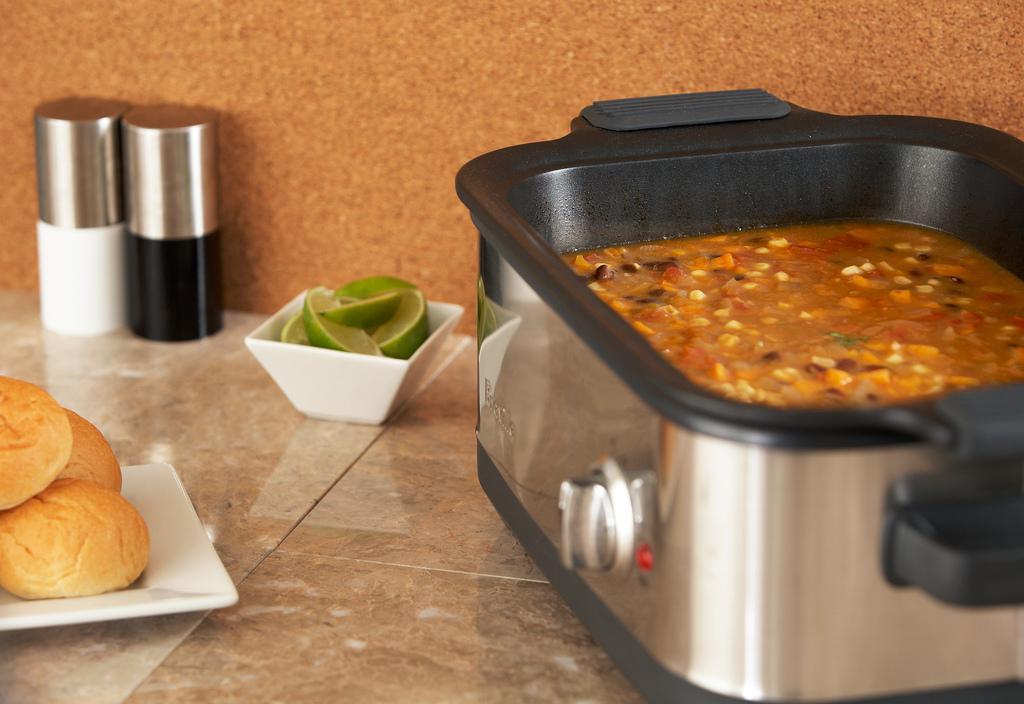Please provide a concise description of this image. In this image I can see the brown colored surface and on it I can see a plate which is white in color with few buns on it. I can see a bowl with few lemon pieces in it and I can see few bottles which are black, white and silver in color. I can see a electronic gadget with some food item in it. In the background I can see the brown colored wall. 